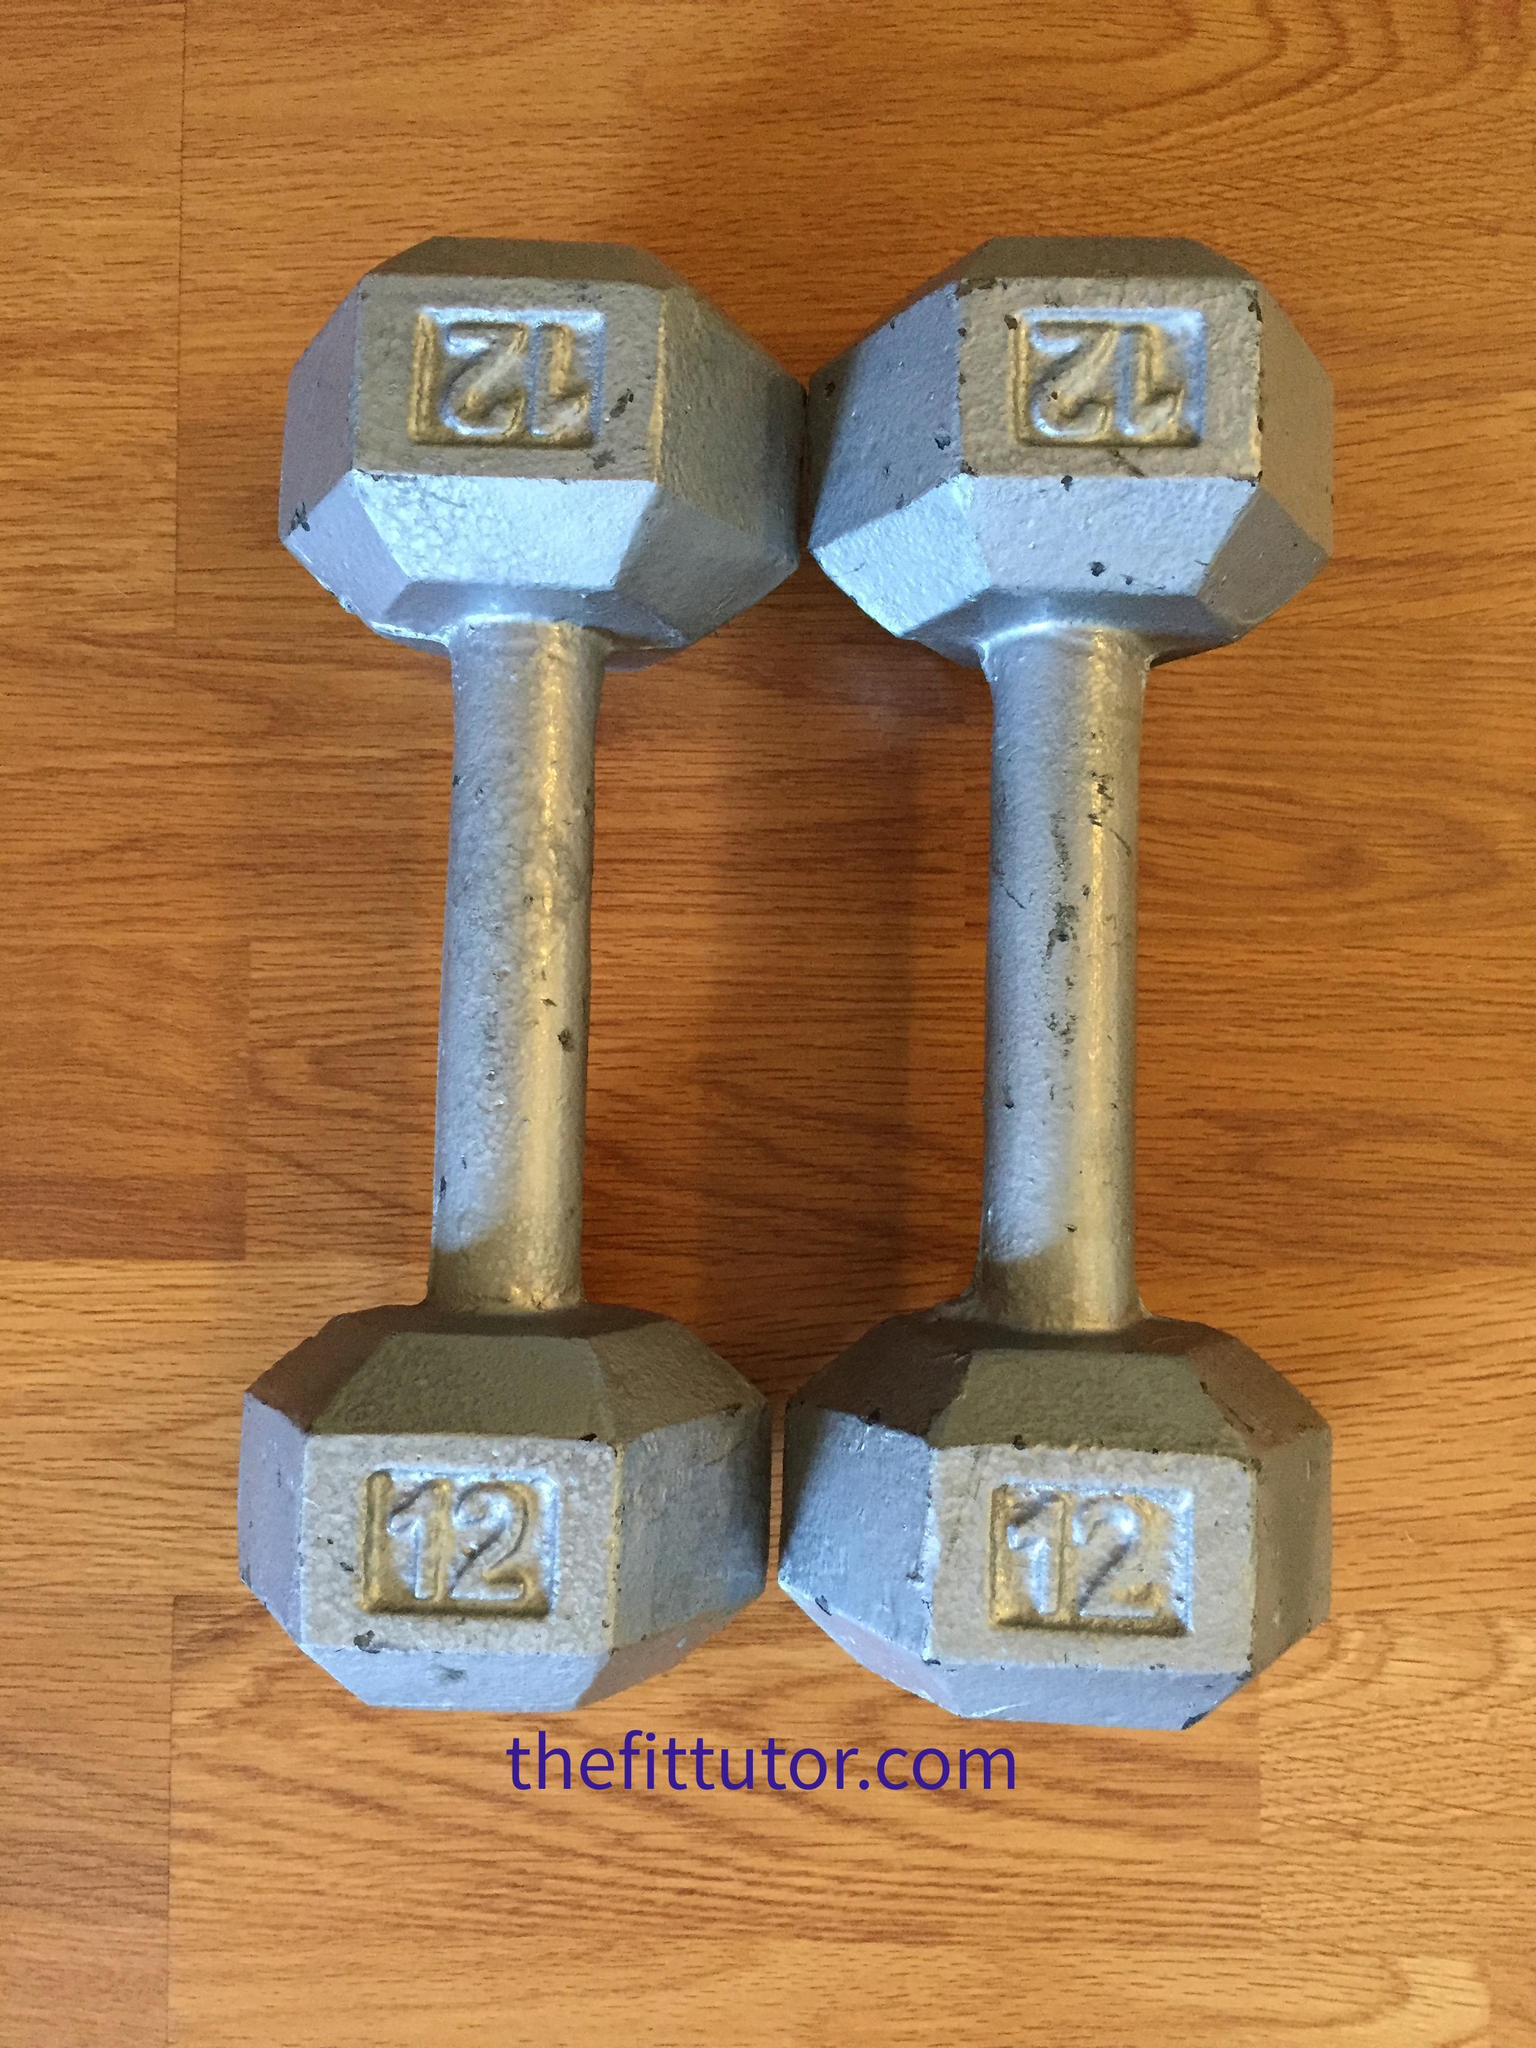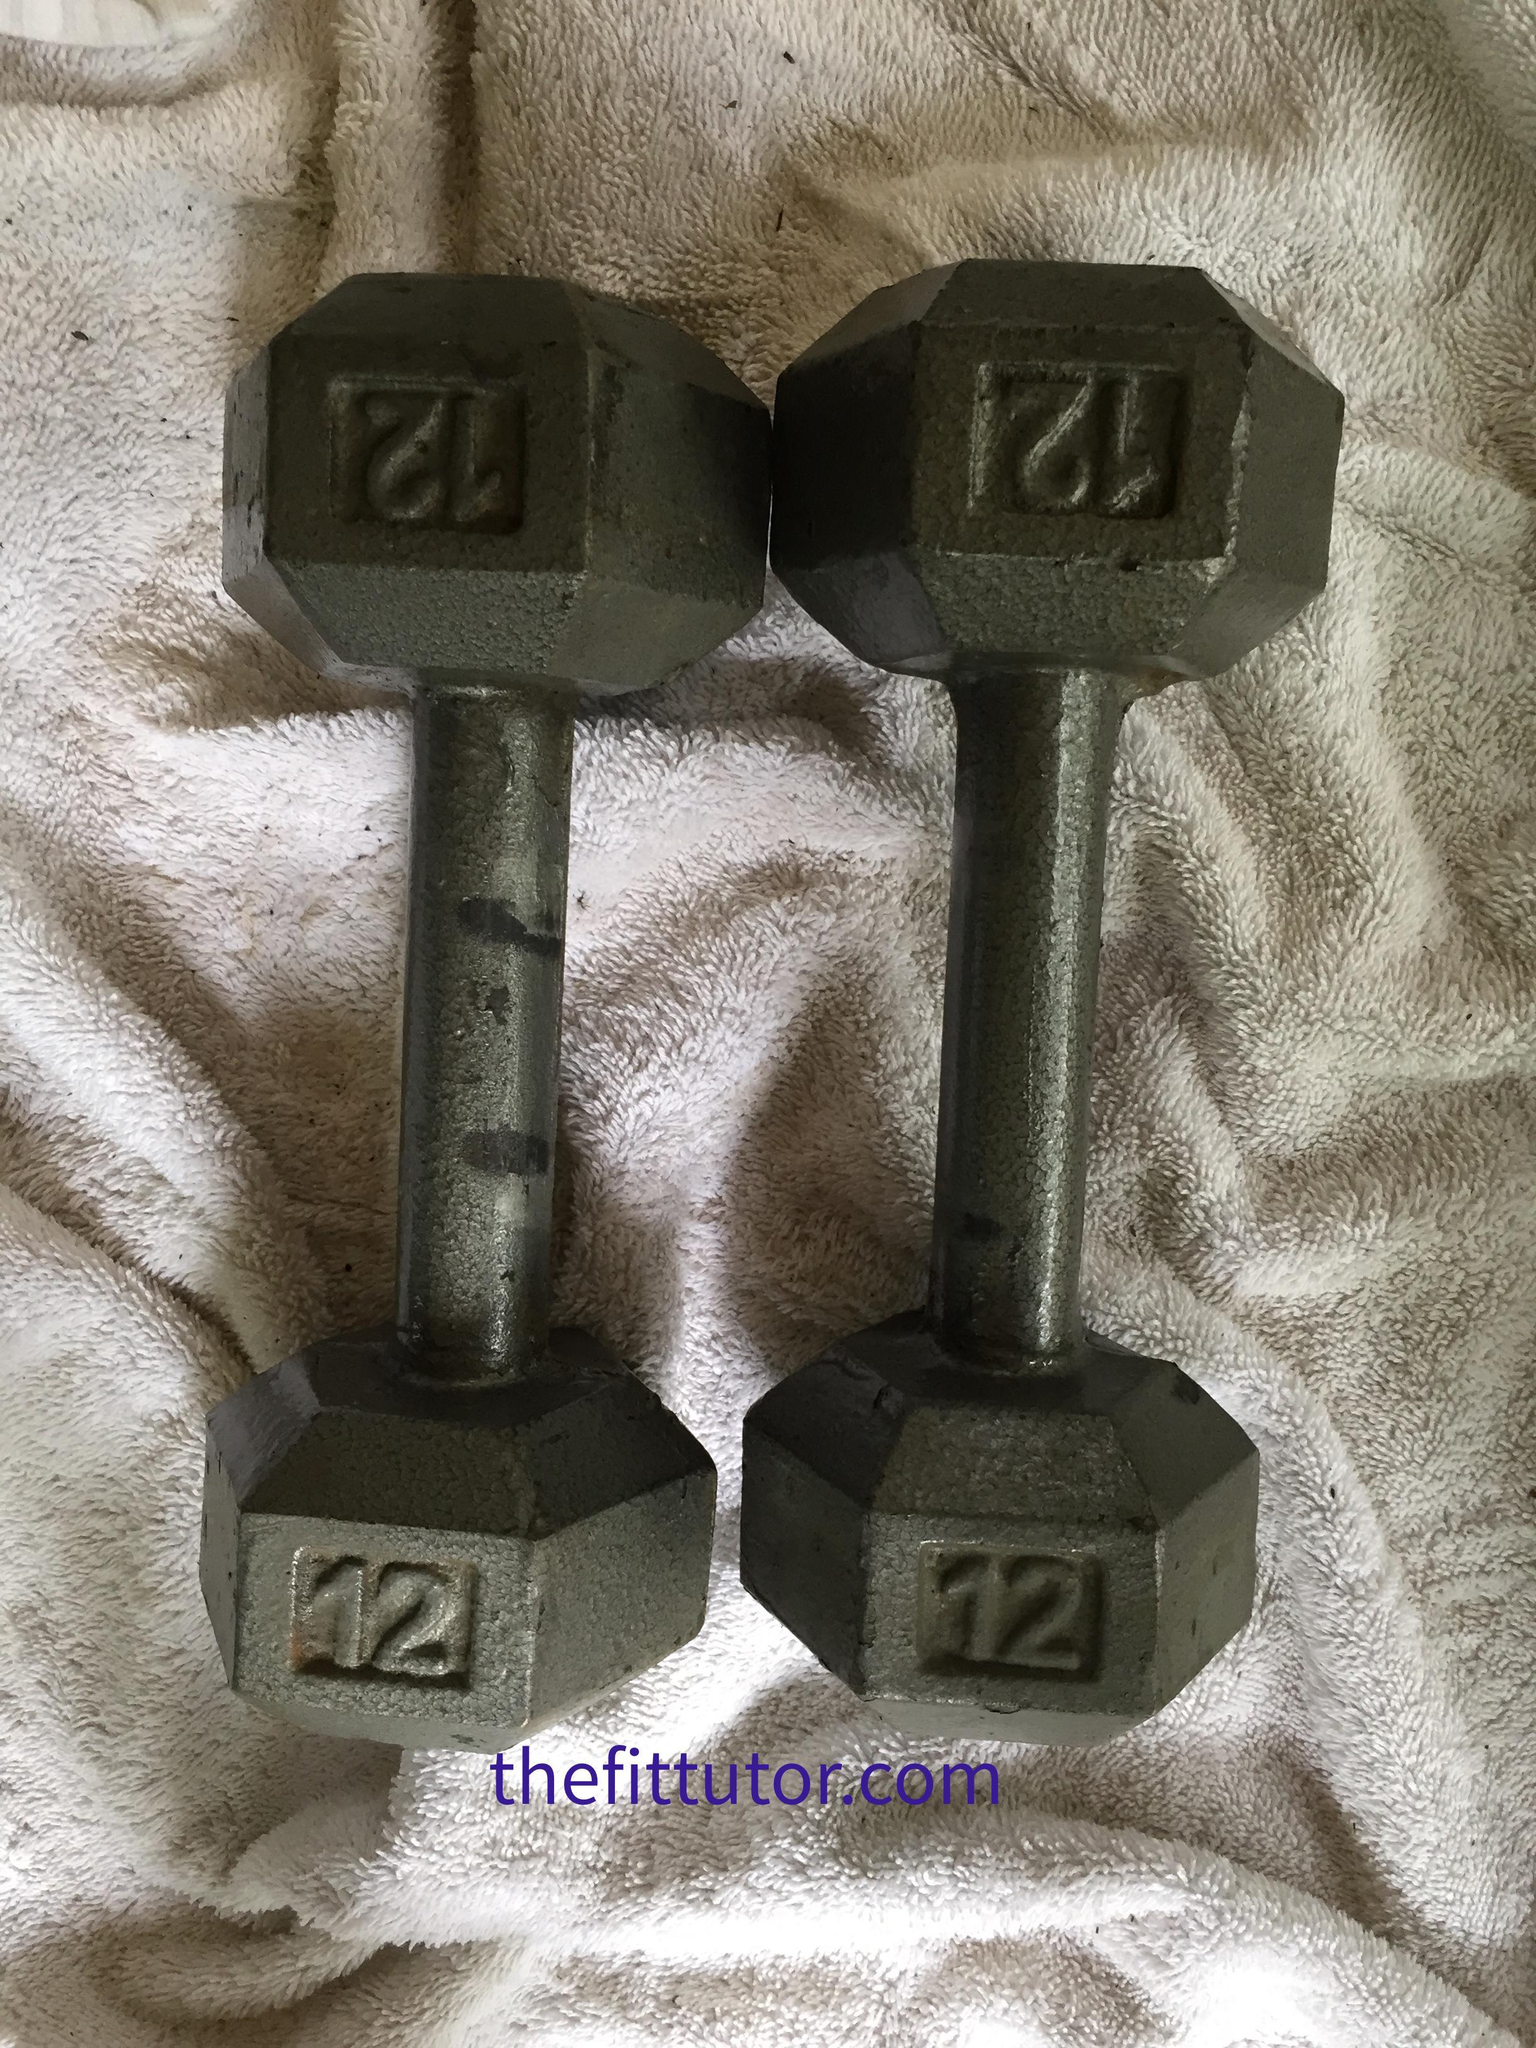The first image is the image on the left, the second image is the image on the right. Assess this claim about the two images: "There are exactly four objects.". Correct or not? Answer yes or no. Yes. The first image is the image on the left, the second image is the image on the right. Given the left and right images, does the statement "One of the weights has tarnished brown surfaces." hold true? Answer yes or no. No. 